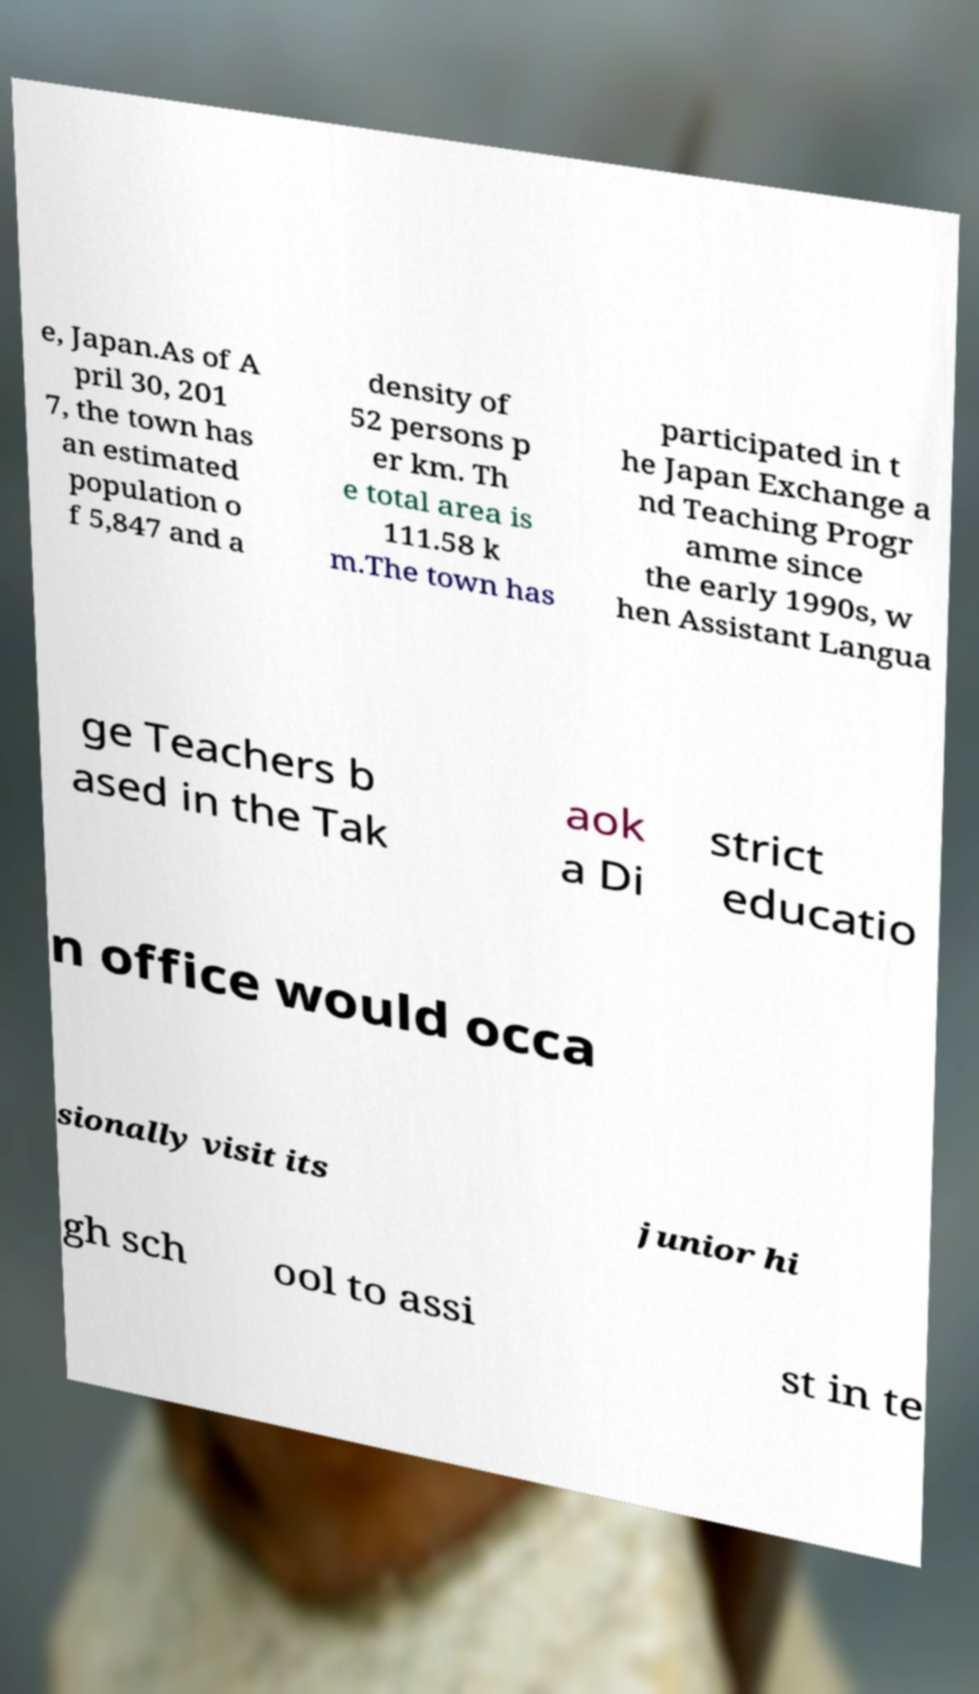I need the written content from this picture converted into text. Can you do that? e, Japan.As of A pril 30, 201 7, the town has an estimated population o f 5,847 and a density of 52 persons p er km. Th e total area is 111.58 k m.The town has participated in t he Japan Exchange a nd Teaching Progr amme since the early 1990s, w hen Assistant Langua ge Teachers b ased in the Tak aok a Di strict educatio n office would occa sionally visit its junior hi gh sch ool to assi st in te 